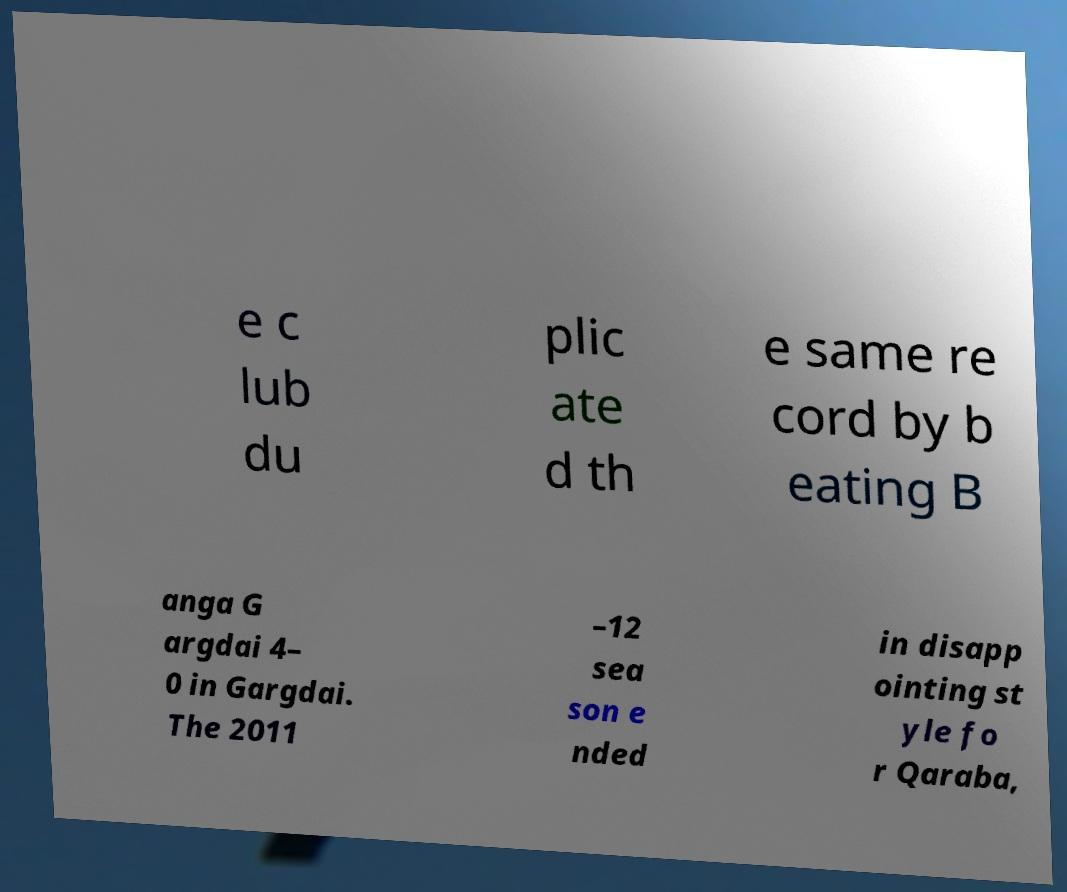Please read and relay the text visible in this image. What does it say? e c lub du plic ate d th e same re cord by b eating B anga G argdai 4– 0 in Gargdai. The 2011 –12 sea son e nded in disapp ointing st yle fo r Qaraba, 